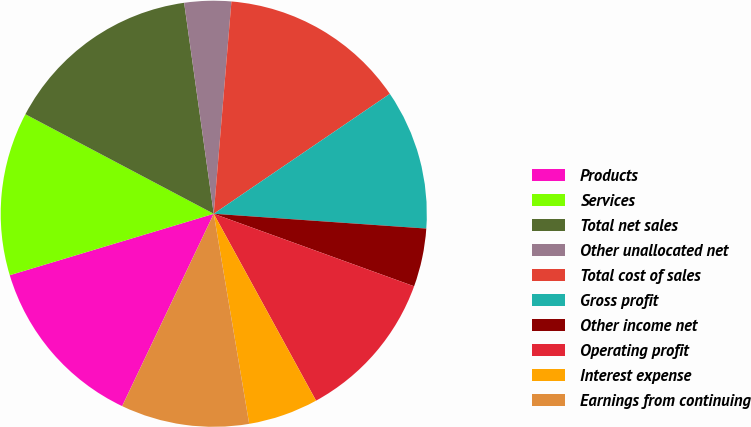Convert chart. <chart><loc_0><loc_0><loc_500><loc_500><pie_chart><fcel>Products<fcel>Services<fcel>Total net sales<fcel>Other unallocated net<fcel>Total cost of sales<fcel>Gross profit<fcel>Other income net<fcel>Operating profit<fcel>Interest expense<fcel>Earnings from continuing<nl><fcel>13.27%<fcel>12.39%<fcel>15.04%<fcel>3.54%<fcel>14.16%<fcel>10.62%<fcel>4.42%<fcel>11.5%<fcel>5.31%<fcel>9.73%<nl></chart> 